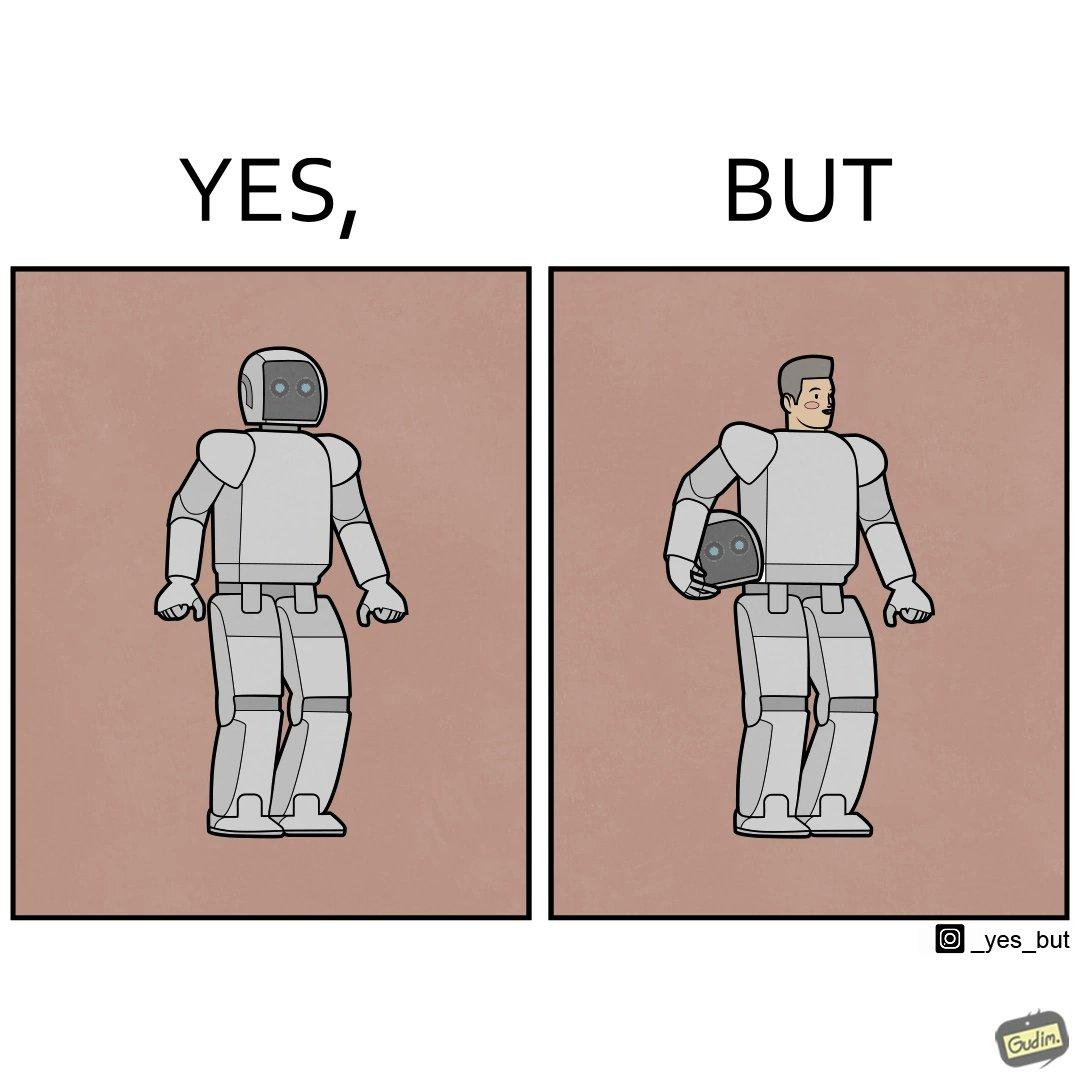Describe what you see in the left and right parts of this image. In the left part of the image: It is a robot In the right part of the image: It is a human in a robot suit 